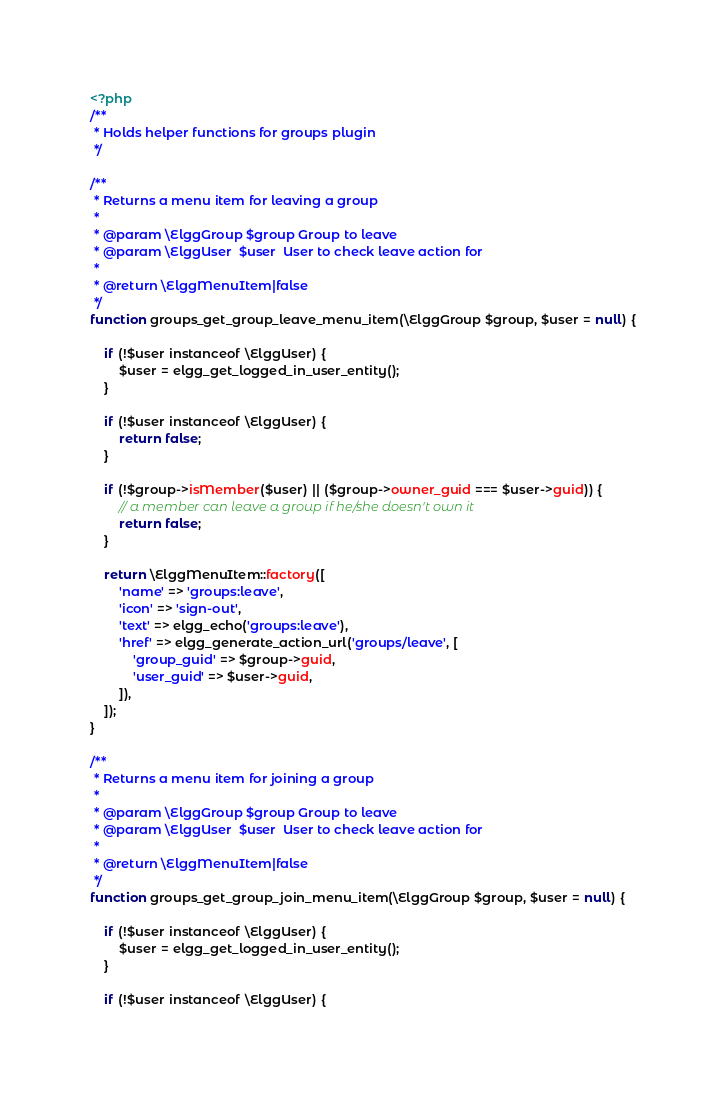<code> <loc_0><loc_0><loc_500><loc_500><_PHP_><?php
/**
 * Holds helper functions for groups plugin
 */

/**
 * Returns a menu item for leaving a group
 *
 * @param \ElggGroup $group Group to leave
 * @param \ElggUser  $user  User to check leave action for
 *
 * @return \ElggMenuItem|false
 */
function groups_get_group_leave_menu_item(\ElggGroup $group, $user = null) {
	
	if (!$user instanceof \ElggUser) {
		$user = elgg_get_logged_in_user_entity();
	}
	
	if (!$user instanceof \ElggUser) {
		return false;
	}
	
	if (!$group->isMember($user) || ($group->owner_guid === $user->guid)) {
		// a member can leave a group if he/she doesn't own it
		return false;
	}
	
	return \ElggMenuItem::factory([
		'name' => 'groups:leave',
		'icon' => 'sign-out',
		'text' => elgg_echo('groups:leave'),
		'href' => elgg_generate_action_url('groups/leave', [
			'group_guid' => $group->guid,
			'user_guid' => $user->guid,
		]),
	]);
}

/**
 * Returns a menu item for joining a group
 *
 * @param \ElggGroup $group Group to leave
 * @param \ElggUser  $user  User to check leave action for
 *
 * @return \ElggMenuItem|false
 */
function groups_get_group_join_menu_item(\ElggGroup $group, $user = null) {
	
	if (!$user instanceof \ElggUser) {
		$user = elgg_get_logged_in_user_entity();
	}
	
	if (!$user instanceof \ElggUser) {</code> 